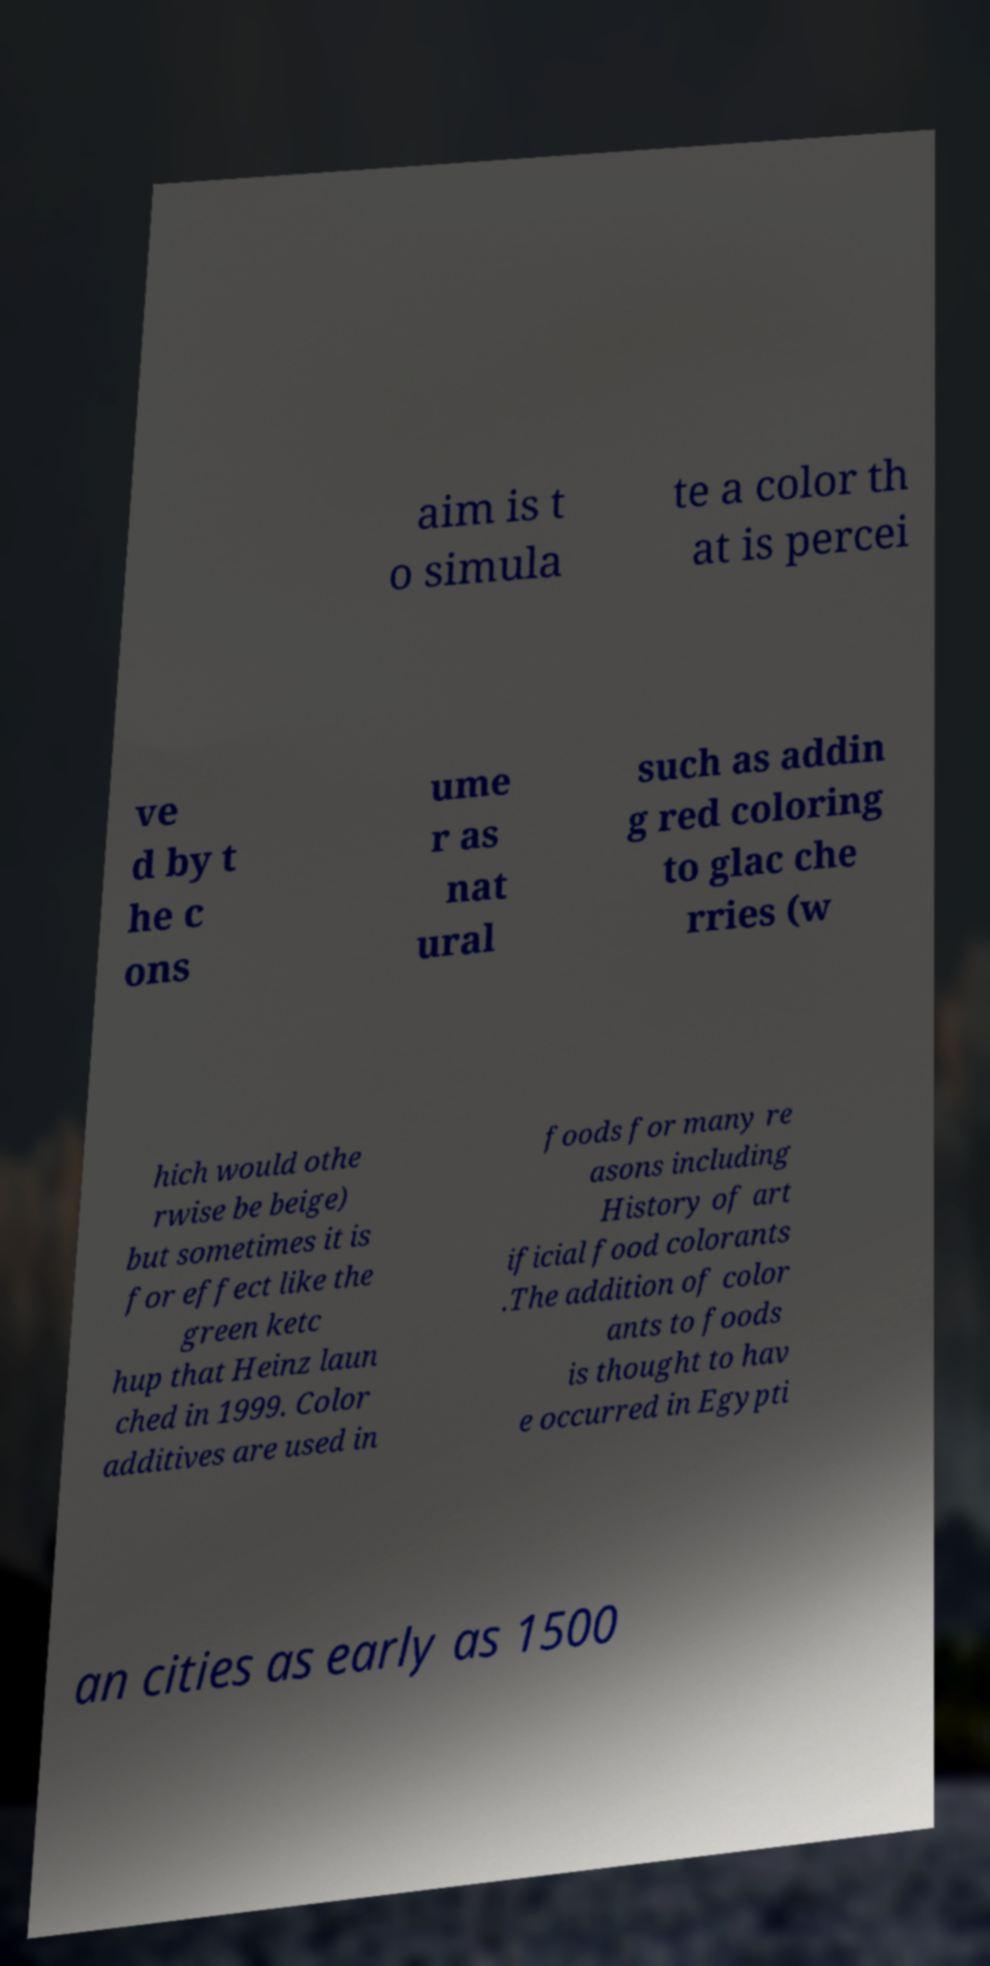Please identify and transcribe the text found in this image. aim is t o simula te a color th at is percei ve d by t he c ons ume r as nat ural such as addin g red coloring to glac che rries (w hich would othe rwise be beige) but sometimes it is for effect like the green ketc hup that Heinz laun ched in 1999. Color additives are used in foods for many re asons including History of art ificial food colorants .The addition of color ants to foods is thought to hav e occurred in Egypti an cities as early as 1500 